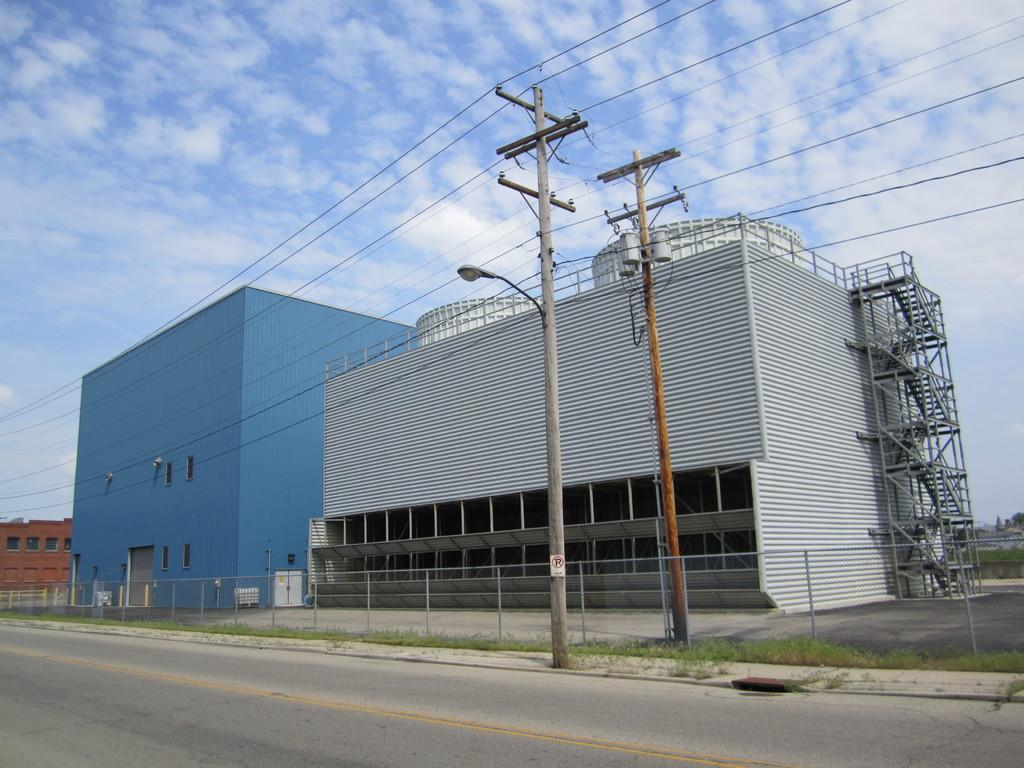What type of structures can be seen in the image? There are buildings in the image. What else can be seen besides the buildings? There are poles and a fence beside the road in the image. What is visible in the sky in the image? There are clouds in the sky in the image. What type of invention is being demonstrated in the image? There is no invention being demonstrated in the image; it features buildings, poles, a fence, and clouds. What scientific experiment is being conducted in the image? There is no scientific experiment being conducted in the image; it is a scene with buildings, poles, a fence, and clouds. 